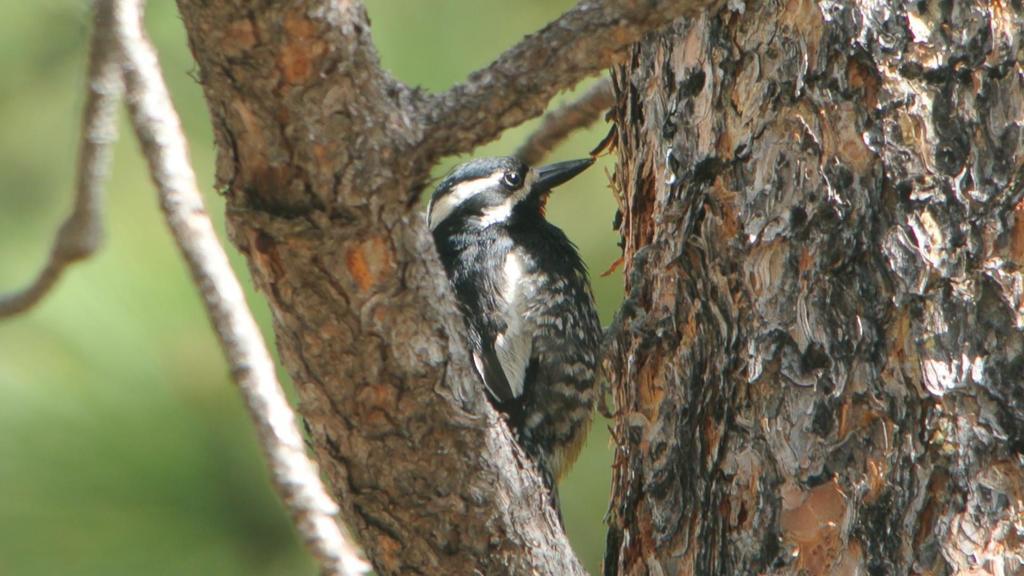Can you describe this image briefly? In this picture we can see a bird near a tree looking somewhere. 